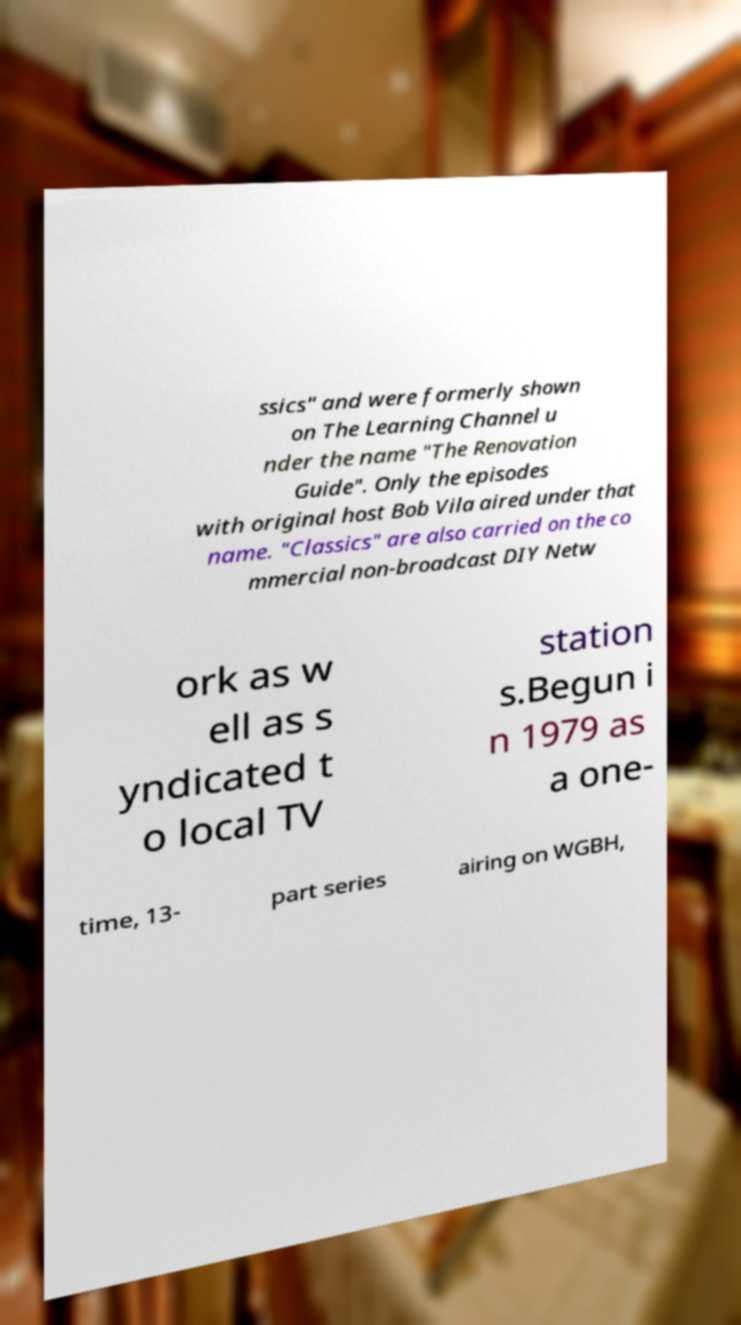For documentation purposes, I need the text within this image transcribed. Could you provide that? ssics" and were formerly shown on The Learning Channel u nder the name "The Renovation Guide". Only the episodes with original host Bob Vila aired under that name. "Classics" are also carried on the co mmercial non-broadcast DIY Netw ork as w ell as s yndicated t o local TV station s.Begun i n 1979 as a one- time, 13- part series airing on WGBH, 